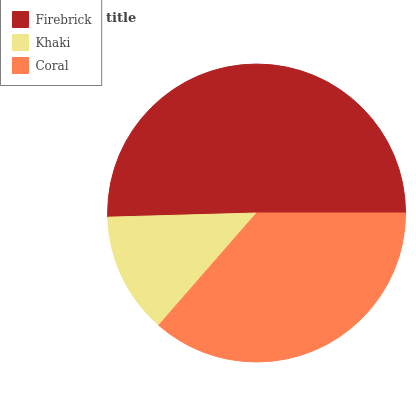Is Khaki the minimum?
Answer yes or no. Yes. Is Firebrick the maximum?
Answer yes or no. Yes. Is Coral the minimum?
Answer yes or no. No. Is Coral the maximum?
Answer yes or no. No. Is Coral greater than Khaki?
Answer yes or no. Yes. Is Khaki less than Coral?
Answer yes or no. Yes. Is Khaki greater than Coral?
Answer yes or no. No. Is Coral less than Khaki?
Answer yes or no. No. Is Coral the high median?
Answer yes or no. Yes. Is Coral the low median?
Answer yes or no. Yes. Is Firebrick the high median?
Answer yes or no. No. Is Firebrick the low median?
Answer yes or no. No. 